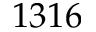<formula> <loc_0><loc_0><loc_500><loc_500>1 3 1 6</formula> 